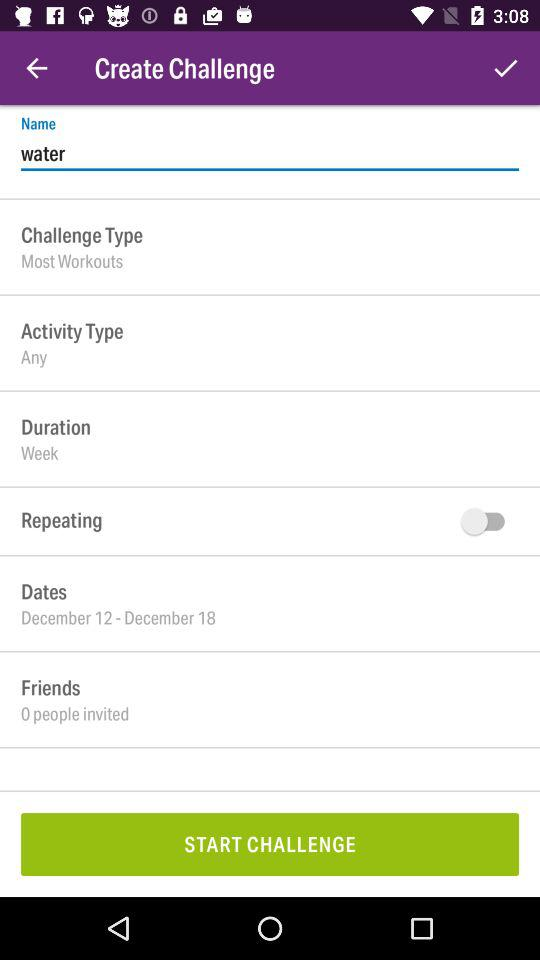What is the status of "Repeating"? The status of "Repeating" is "off". 